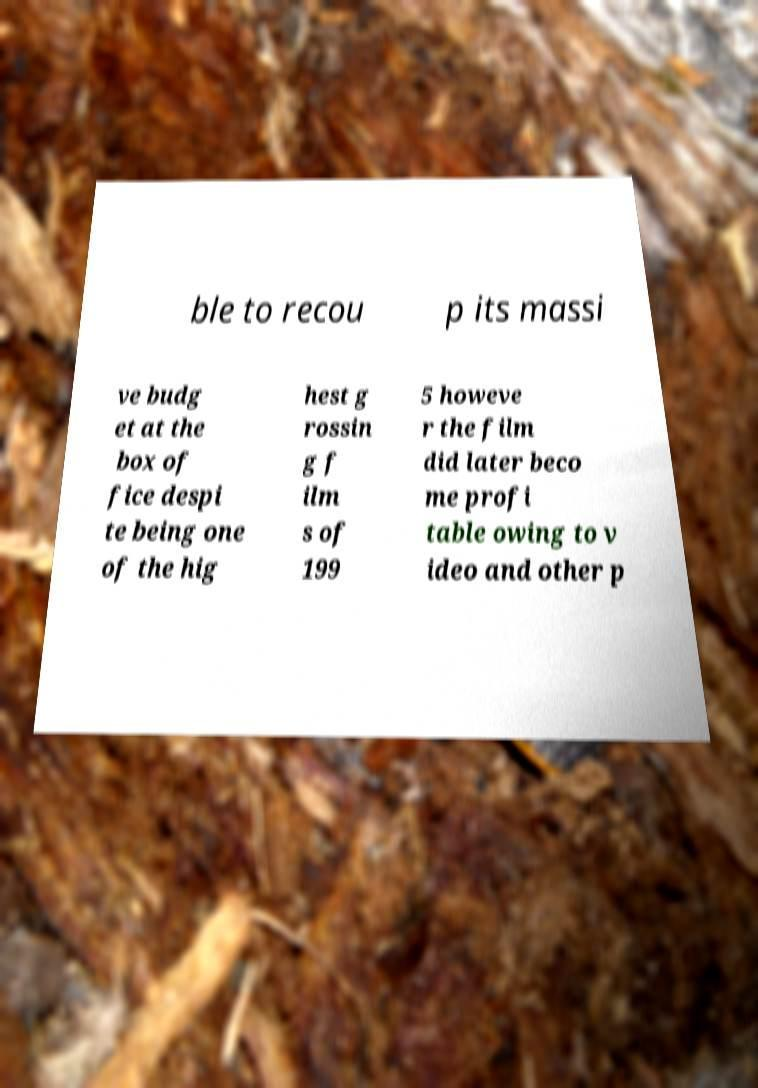Please read and relay the text visible in this image. What does it say? ble to recou p its massi ve budg et at the box of fice despi te being one of the hig hest g rossin g f ilm s of 199 5 howeve r the film did later beco me profi table owing to v ideo and other p 